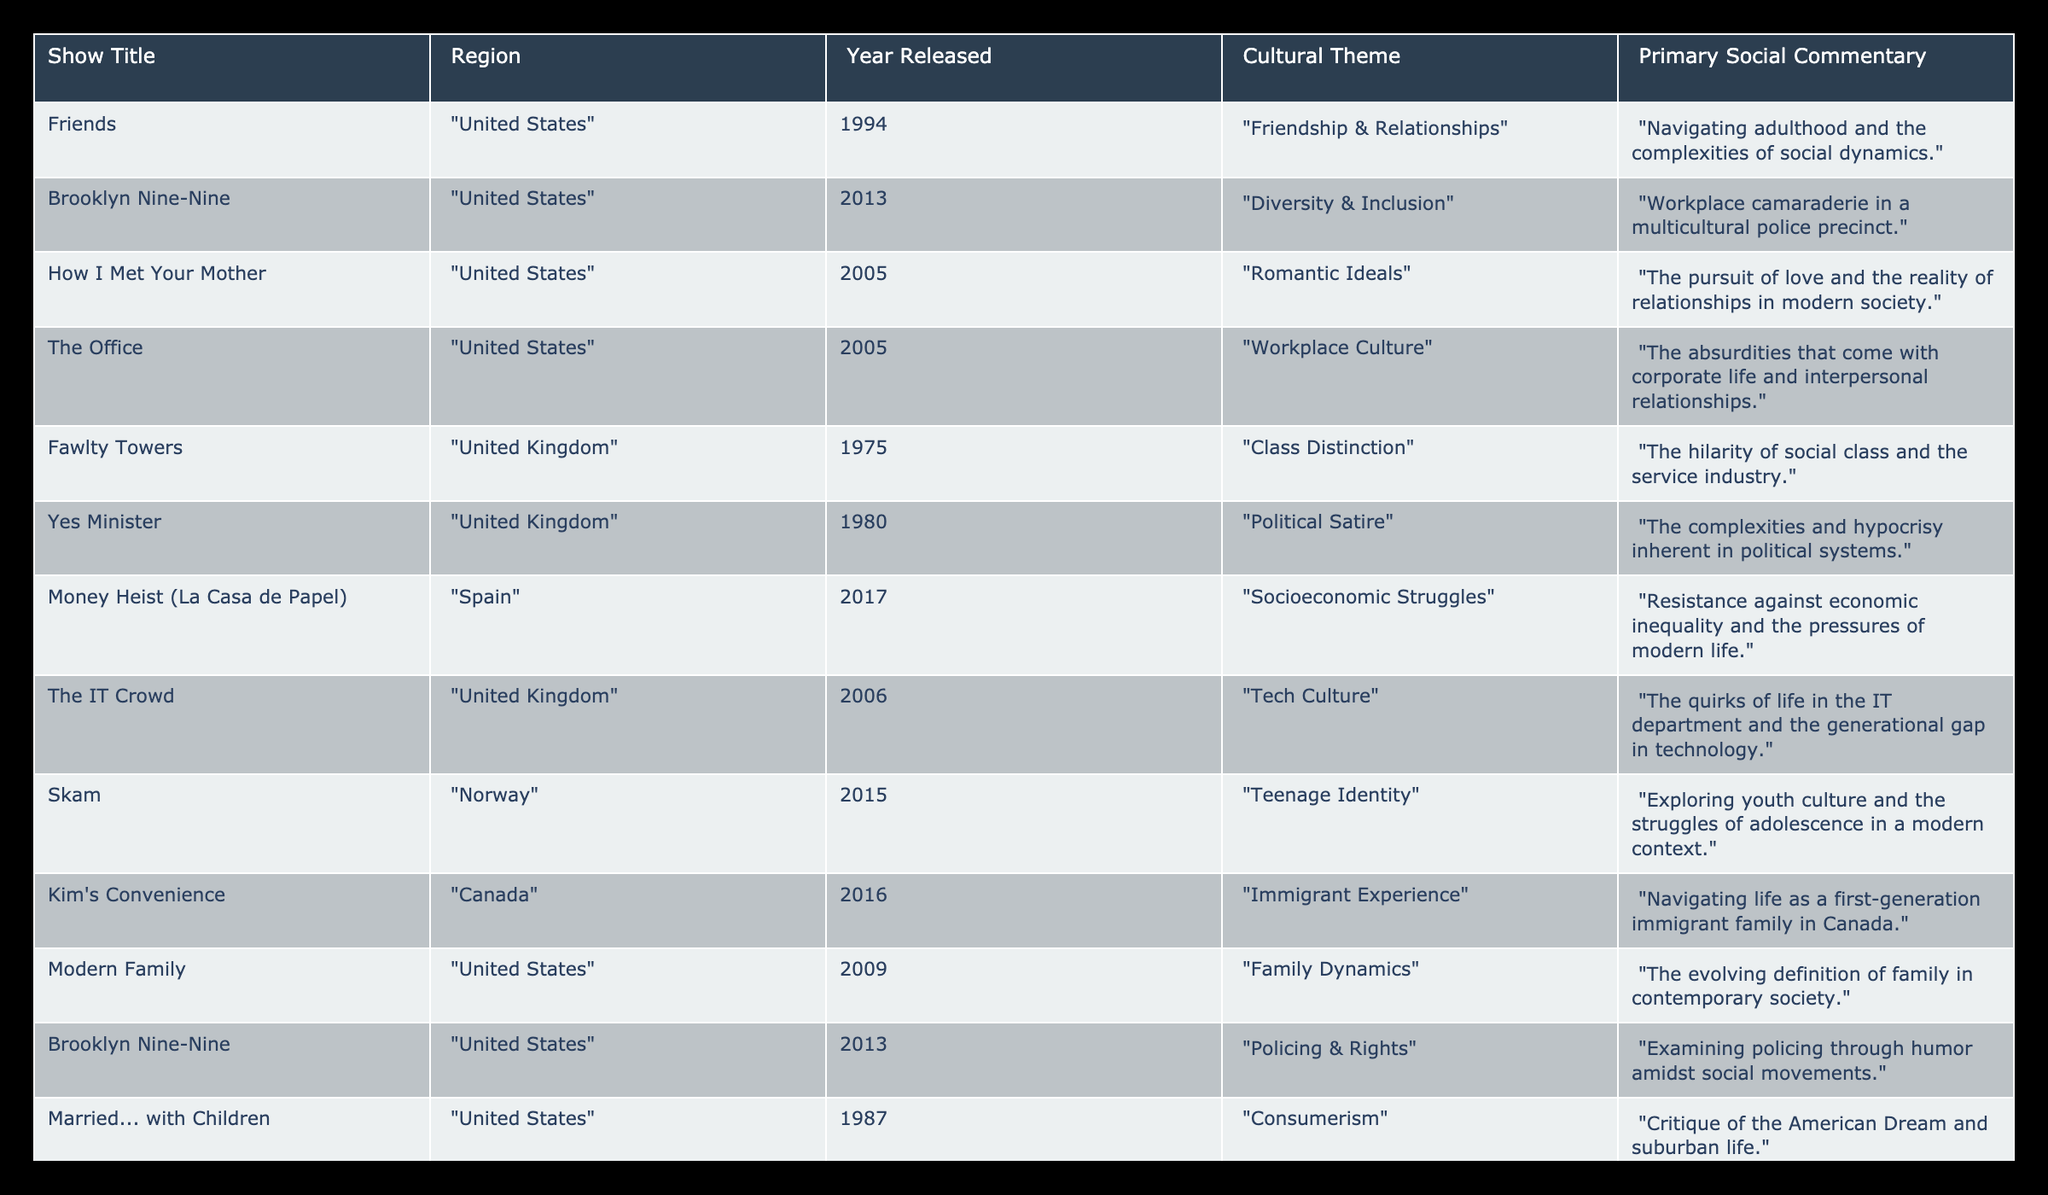What region does "Friends" come from? The table lists the region for each sitcom under the "Region" column. Checking the row for "Friends," we see that it is from the "United States."
Answer: United States What cultural theme is associated with "How I Met Your Mother"? The cultural theme for each show is listed in the "Cultural Theme" column. For "How I Met Your Mother," the theme is "Romantic Ideals."
Answer: Romantic Ideals How many shows focus on themes related to diversity or inclusion? By reviewing the "Cultural Theme" column, we can identify shows addressing diversity. "Brooklyn Nine-Nine" appears twice under different themes: "Diversity & Inclusion" and "Policing & Rights." Therefore, there are two instances but only one unique show related to diversity.
Answer: 1 Is "Fawlty Towers" a United States sitcom? We refer to the "Region" column for "Fawlty Towers." It is listed under the "United Kingdom," not the United States, which makes the statement false.
Answer: No Which sitcom contains the theme of "Socioeconomic Struggles"? Looking at the "Cultural Theme" column, "Money Heist (La Casa de Papel)" is identified with the theme of "Socioeconomic Struggles."
Answer: Money Heist (La Casa de Papel) What is the average year of release for the shows from Canada? The shows from Canada listed are "Kim's Convenience" and "Schitt's Creek," released in 2016 and 2015, respectively. Calculating the average: (2016 + 2015) / 2 = 2015.5. Thus, the average year rounds to 2016.
Answer: 2016 How many sitcoms were released in the year 2005? The "Year Released" column indicates two shows released in 2005: "How I Met Your Mother" and "The Office." Therefore, the count of sitcoms is 2.
Answer: 2 Does "Brooklyn Nine-Nine" address workplace culture in its themes? "Brooklyn Nine-Nine" is associated with "Diversity & Inclusion" and "Policing & Rights." There is no reference to workplace culture for this show. Therefore, the answer is no.
Answer: No Which cultural theme appears most frequently in the shows listed? We can analyze the "Cultural Theme" column. The themes are varied, but both "Diversity & Inclusion" and "Policing & Rights" are linked to "Brooklyn Nine-Nine," which allows those themes to stand out. However, they are related to a single show; all others are unique. Thus, while several themes exist, none repeat across different shows.
Answer: None 